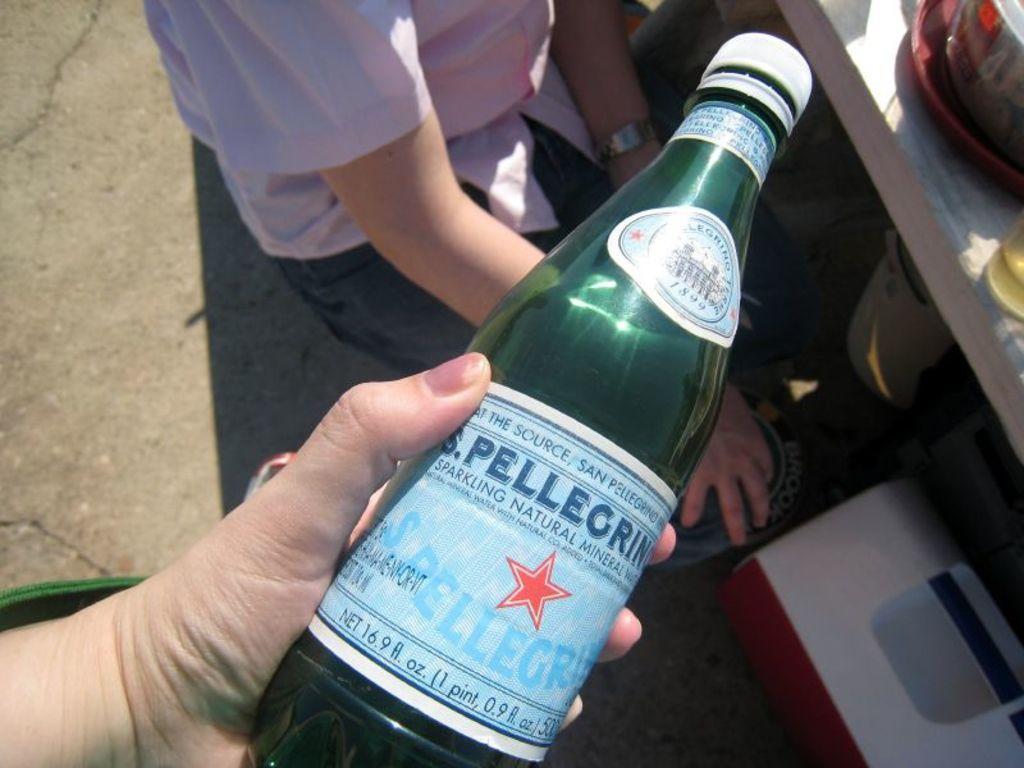Can you describe this image briefly? In this image in the center there is a bottle which is holded by a person and there is some text written on the bottle, at the top there is a person. On the right side there is a table which is white in colour and there are objects on the table. Under the table there is a white colour object. 